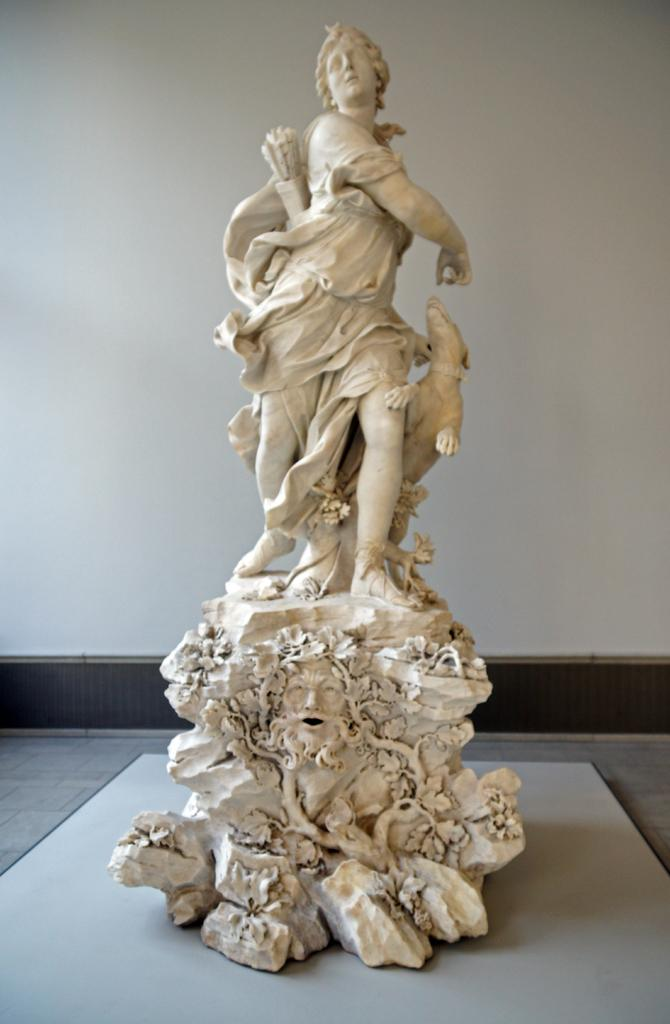What types of statues are present in the image? There is a statue of a person and a statue of an animal in the image. What can be seen in the background of the image? There is a white wall in the background of the image. What month is the judge visiting the stranger in the image? There is no judge or stranger present in the image, and therefore no such event can be observed. 